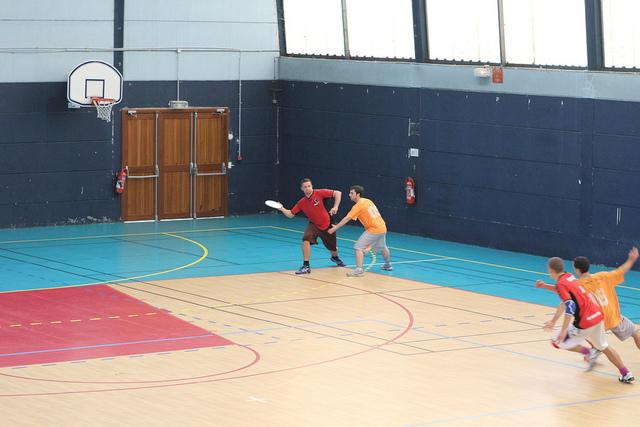What game is usually played on this court?

Choices:
A) badminton
B) tennis
C) basketball
D) volleyball basketball 